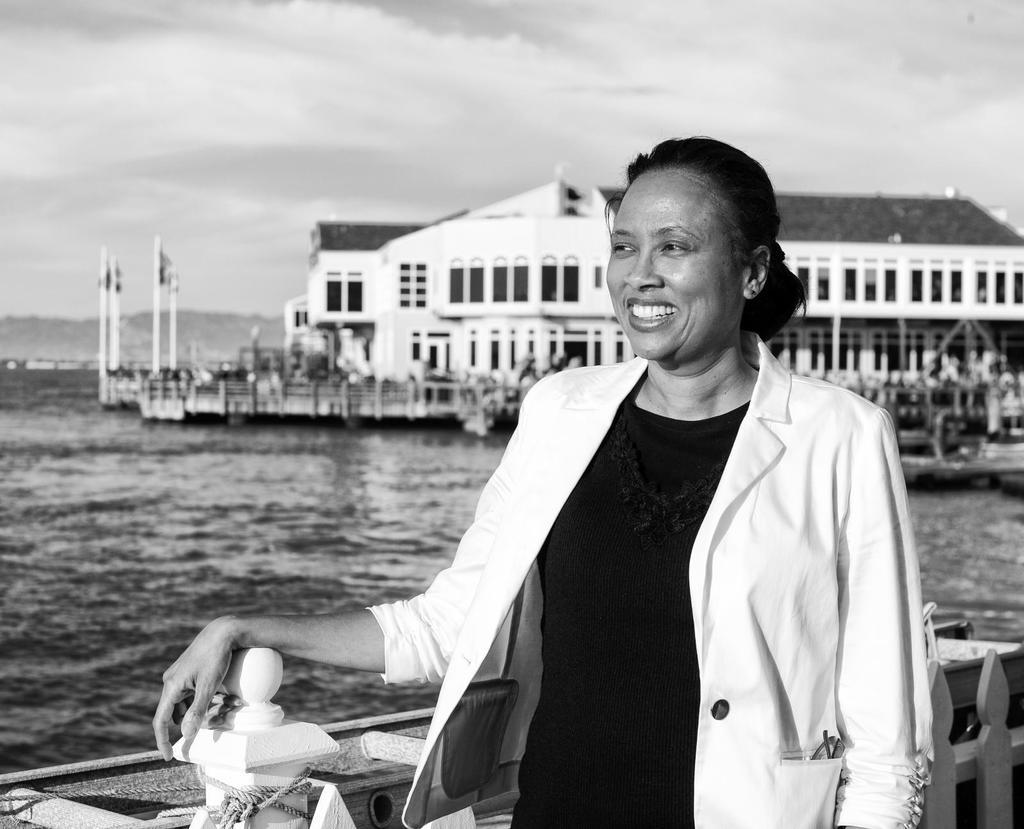Who is the main subject in the image? There is a woman standing in the front of the image. What is the woman doing in the image? The woman is smiling. What can be seen in the center of the image? There is water in the center of the image. What is visible in the background of the image? There are buildings in the background of the image. How would you describe the weather in the image? The sky is cloudy in the image. What type of button can be seen on the woman's shirt in the image? There is no button visible on the woman's shirt in the image. What kind of frame surrounds the image? The image does not have a frame; it is a photograph or digital image without any visible border. 